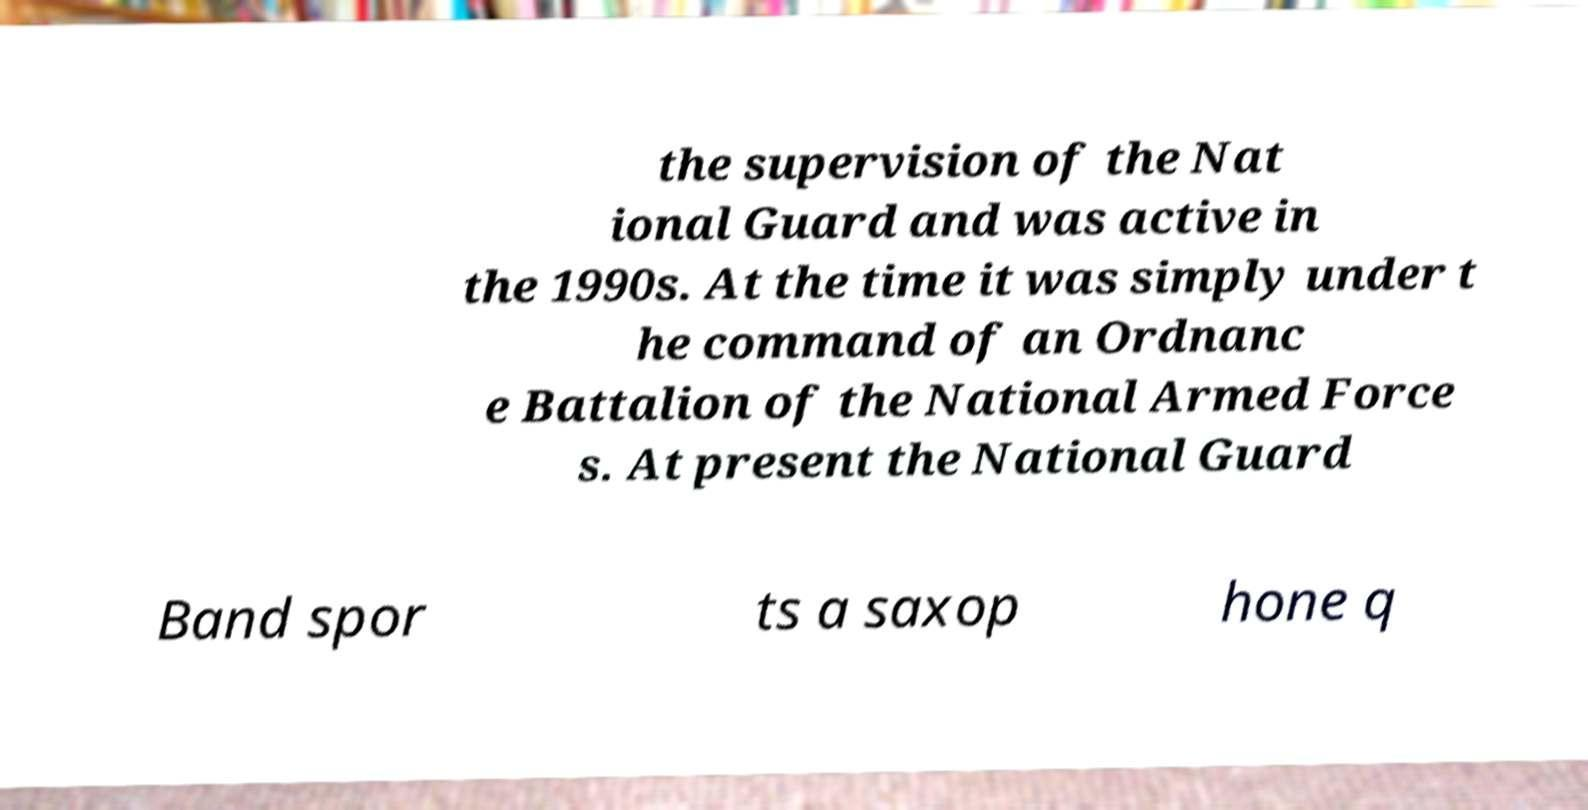Please identify and transcribe the text found in this image. the supervision of the Nat ional Guard and was active in the 1990s. At the time it was simply under t he command of an Ordnanc e Battalion of the National Armed Force s. At present the National Guard Band spor ts a saxop hone q 